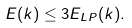Convert formula to latex. <formula><loc_0><loc_0><loc_500><loc_500>E ( k ) \leq 3 E _ { L P } ( k ) .</formula> 